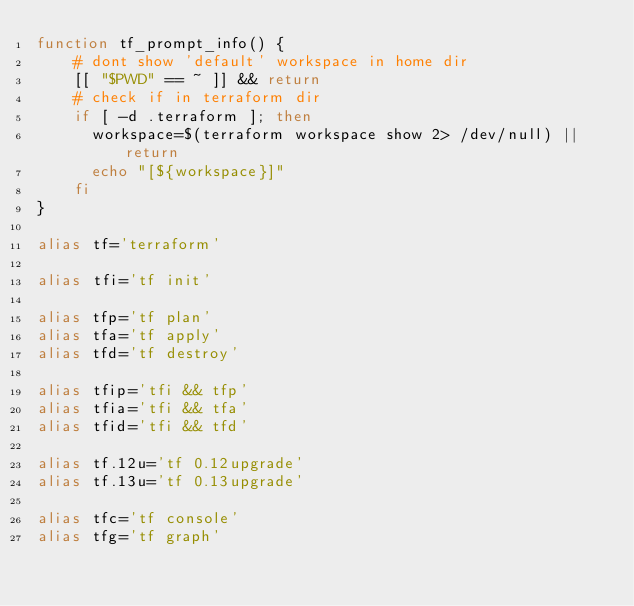<code> <loc_0><loc_0><loc_500><loc_500><_Bash_>function tf_prompt_info() {
    # dont show 'default' workspace in home dir
    [[ "$PWD" == ~ ]] && return
    # check if in terraform dir
    if [ -d .terraform ]; then
      workspace=$(terraform workspace show 2> /dev/null) || return
      echo "[${workspace}]"
    fi
}

alias tf='terraform'

alias tfi='tf init'

alias tfp='tf plan'
alias tfa='tf apply'
alias tfd='tf destroy'

alias tfip='tfi && tfp'
alias tfia='tfi && tfa'
alias tfid='tfi && tfd'

alias tf.12u='tf 0.12upgrade'
alias tf.13u='tf 0.13upgrade'

alias tfc='tf console'
alias tfg='tf graph'</code> 